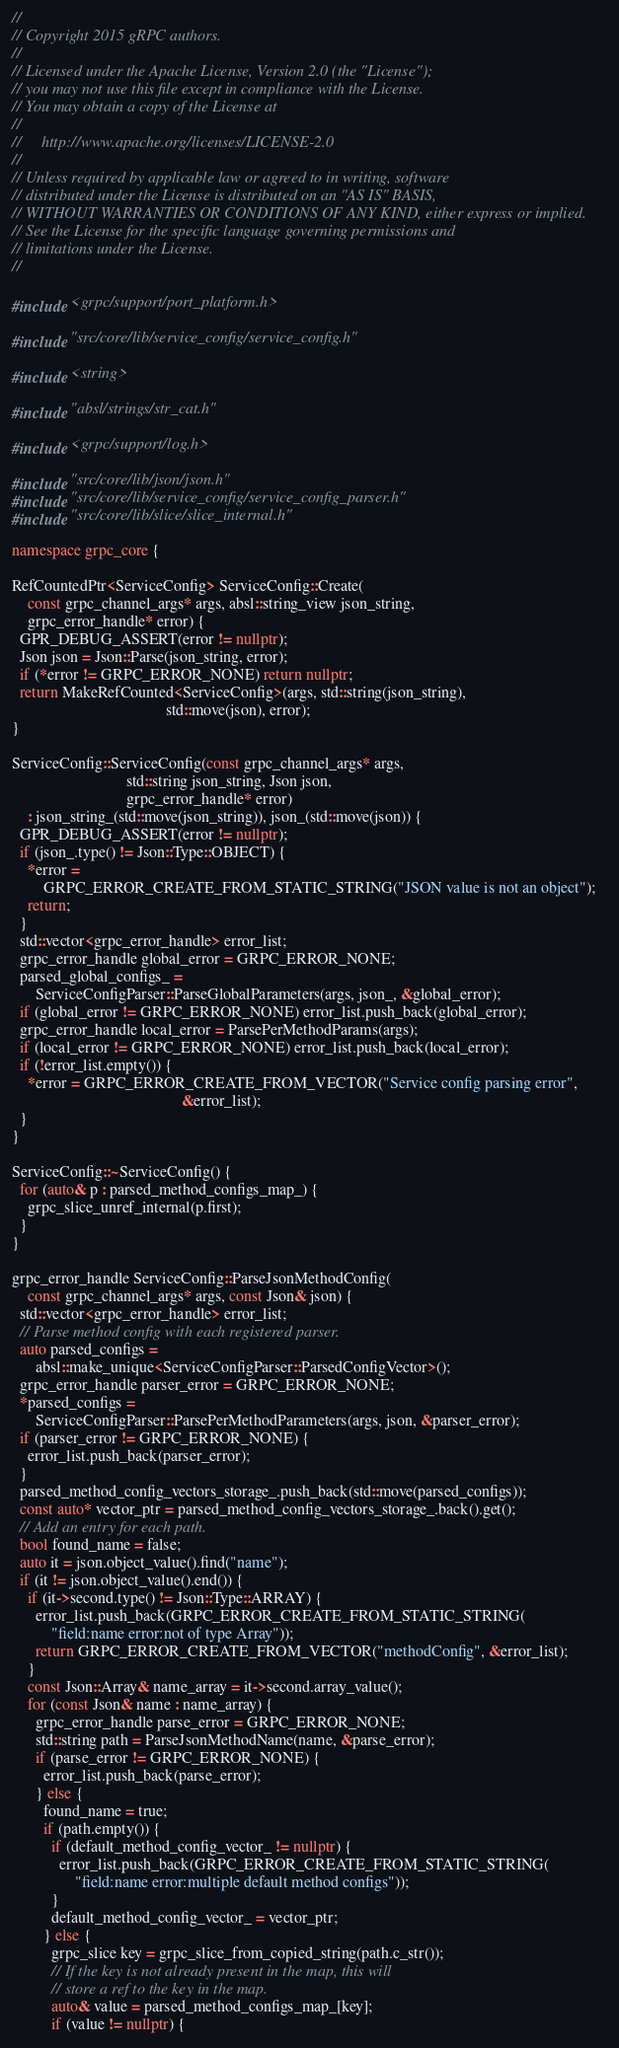<code> <loc_0><loc_0><loc_500><loc_500><_C++_>//
// Copyright 2015 gRPC authors.
//
// Licensed under the Apache License, Version 2.0 (the "License");
// you may not use this file except in compliance with the License.
// You may obtain a copy of the License at
//
//     http://www.apache.org/licenses/LICENSE-2.0
//
// Unless required by applicable law or agreed to in writing, software
// distributed under the License is distributed on an "AS IS" BASIS,
// WITHOUT WARRANTIES OR CONDITIONS OF ANY KIND, either express or implied.
// See the License for the specific language governing permissions and
// limitations under the License.
//

#include <grpc/support/port_platform.h>

#include "src/core/lib/service_config/service_config.h"

#include <string>

#include "absl/strings/str_cat.h"

#include <grpc/support/log.h>

#include "src/core/lib/json/json.h"
#include "src/core/lib/service_config/service_config_parser.h"
#include "src/core/lib/slice/slice_internal.h"

namespace grpc_core {

RefCountedPtr<ServiceConfig> ServiceConfig::Create(
    const grpc_channel_args* args, absl::string_view json_string,
    grpc_error_handle* error) {
  GPR_DEBUG_ASSERT(error != nullptr);
  Json json = Json::Parse(json_string, error);
  if (*error != GRPC_ERROR_NONE) return nullptr;
  return MakeRefCounted<ServiceConfig>(args, std::string(json_string),
                                       std::move(json), error);
}

ServiceConfig::ServiceConfig(const grpc_channel_args* args,
                             std::string json_string, Json json,
                             grpc_error_handle* error)
    : json_string_(std::move(json_string)), json_(std::move(json)) {
  GPR_DEBUG_ASSERT(error != nullptr);
  if (json_.type() != Json::Type::OBJECT) {
    *error =
        GRPC_ERROR_CREATE_FROM_STATIC_STRING("JSON value is not an object");
    return;
  }
  std::vector<grpc_error_handle> error_list;
  grpc_error_handle global_error = GRPC_ERROR_NONE;
  parsed_global_configs_ =
      ServiceConfigParser::ParseGlobalParameters(args, json_, &global_error);
  if (global_error != GRPC_ERROR_NONE) error_list.push_back(global_error);
  grpc_error_handle local_error = ParsePerMethodParams(args);
  if (local_error != GRPC_ERROR_NONE) error_list.push_back(local_error);
  if (!error_list.empty()) {
    *error = GRPC_ERROR_CREATE_FROM_VECTOR("Service config parsing error",
                                           &error_list);
  }
}

ServiceConfig::~ServiceConfig() {
  for (auto& p : parsed_method_configs_map_) {
    grpc_slice_unref_internal(p.first);
  }
}

grpc_error_handle ServiceConfig::ParseJsonMethodConfig(
    const grpc_channel_args* args, const Json& json) {
  std::vector<grpc_error_handle> error_list;
  // Parse method config with each registered parser.
  auto parsed_configs =
      absl::make_unique<ServiceConfigParser::ParsedConfigVector>();
  grpc_error_handle parser_error = GRPC_ERROR_NONE;
  *parsed_configs =
      ServiceConfigParser::ParsePerMethodParameters(args, json, &parser_error);
  if (parser_error != GRPC_ERROR_NONE) {
    error_list.push_back(parser_error);
  }
  parsed_method_config_vectors_storage_.push_back(std::move(parsed_configs));
  const auto* vector_ptr = parsed_method_config_vectors_storage_.back().get();
  // Add an entry for each path.
  bool found_name = false;
  auto it = json.object_value().find("name");
  if (it != json.object_value().end()) {
    if (it->second.type() != Json::Type::ARRAY) {
      error_list.push_back(GRPC_ERROR_CREATE_FROM_STATIC_STRING(
          "field:name error:not of type Array"));
      return GRPC_ERROR_CREATE_FROM_VECTOR("methodConfig", &error_list);
    }
    const Json::Array& name_array = it->second.array_value();
    for (const Json& name : name_array) {
      grpc_error_handle parse_error = GRPC_ERROR_NONE;
      std::string path = ParseJsonMethodName(name, &parse_error);
      if (parse_error != GRPC_ERROR_NONE) {
        error_list.push_back(parse_error);
      } else {
        found_name = true;
        if (path.empty()) {
          if (default_method_config_vector_ != nullptr) {
            error_list.push_back(GRPC_ERROR_CREATE_FROM_STATIC_STRING(
                "field:name error:multiple default method configs"));
          }
          default_method_config_vector_ = vector_ptr;
        } else {
          grpc_slice key = grpc_slice_from_copied_string(path.c_str());
          // If the key is not already present in the map, this will
          // store a ref to the key in the map.
          auto& value = parsed_method_configs_map_[key];
          if (value != nullptr) {</code> 